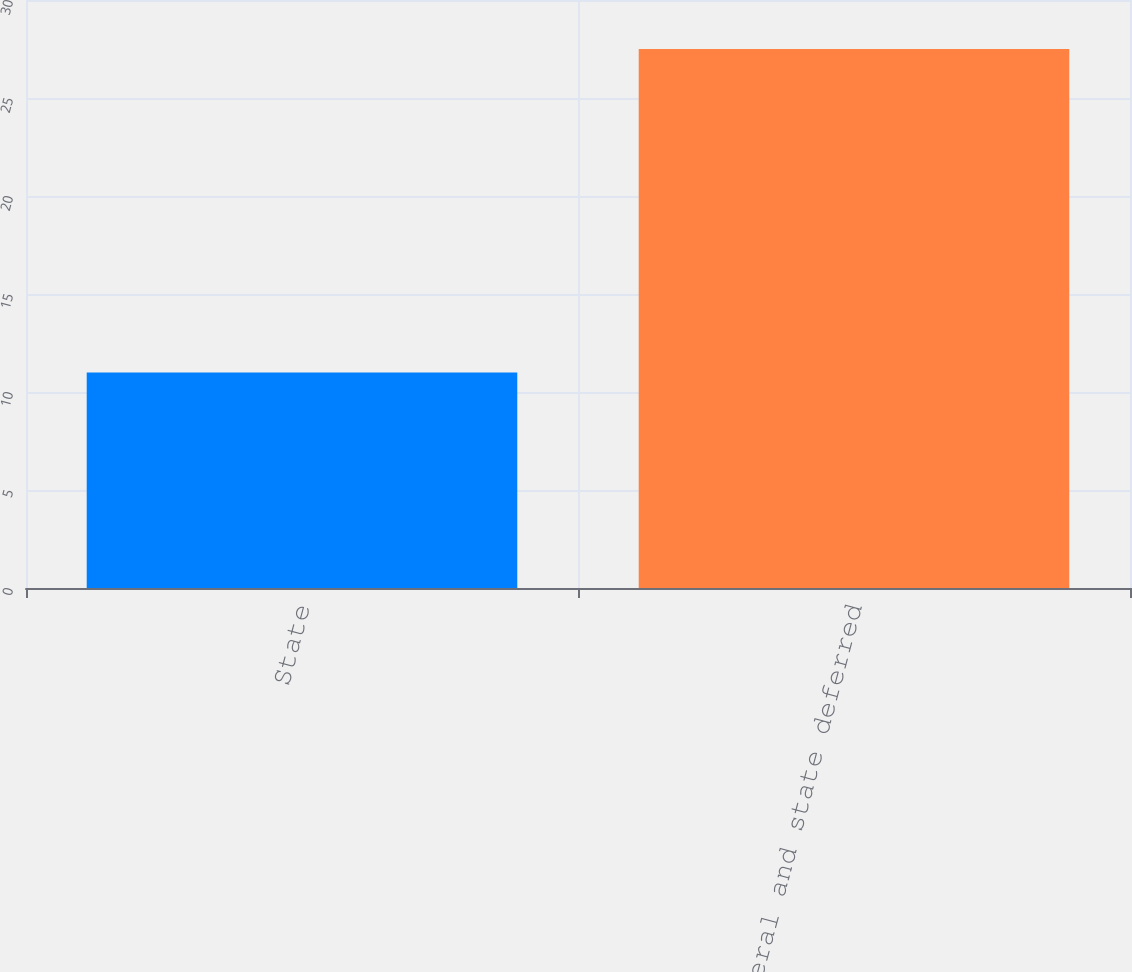Convert chart to OTSL. <chart><loc_0><loc_0><loc_500><loc_500><bar_chart><fcel>State<fcel>Federal and state deferred<nl><fcel>11<fcel>27.5<nl></chart> 